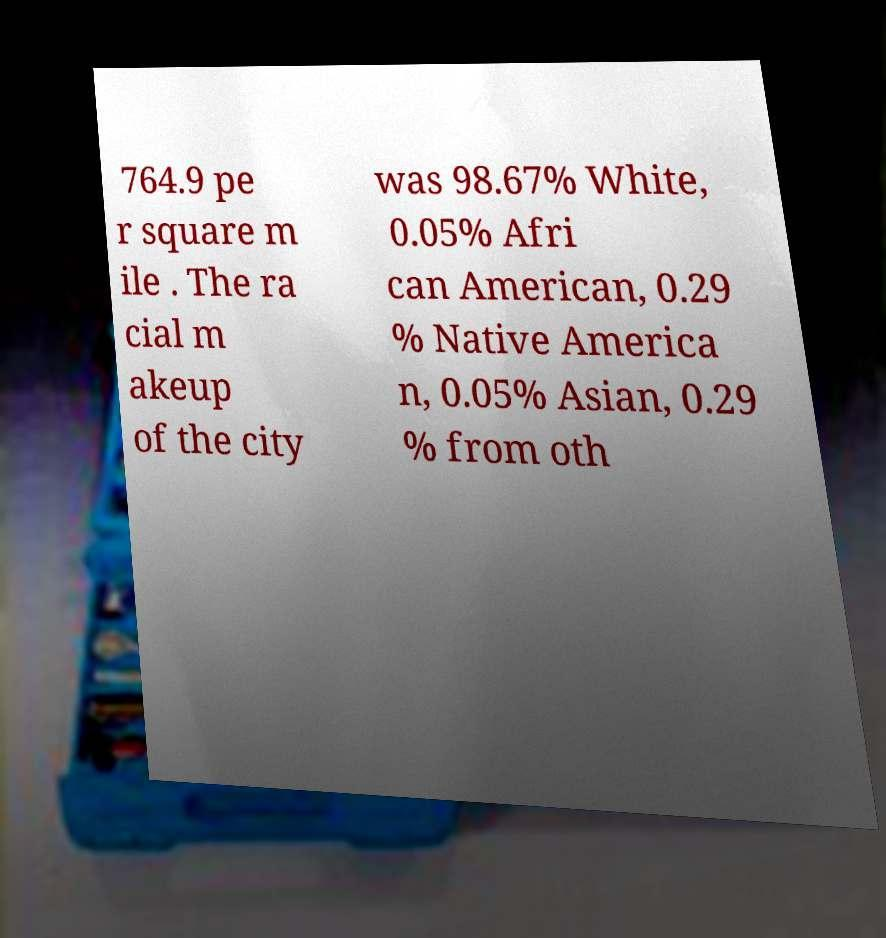There's text embedded in this image that I need extracted. Can you transcribe it verbatim? 764.9 pe r square m ile . The ra cial m akeup of the city was 98.67% White, 0.05% Afri can American, 0.29 % Native America n, 0.05% Asian, 0.29 % from oth 